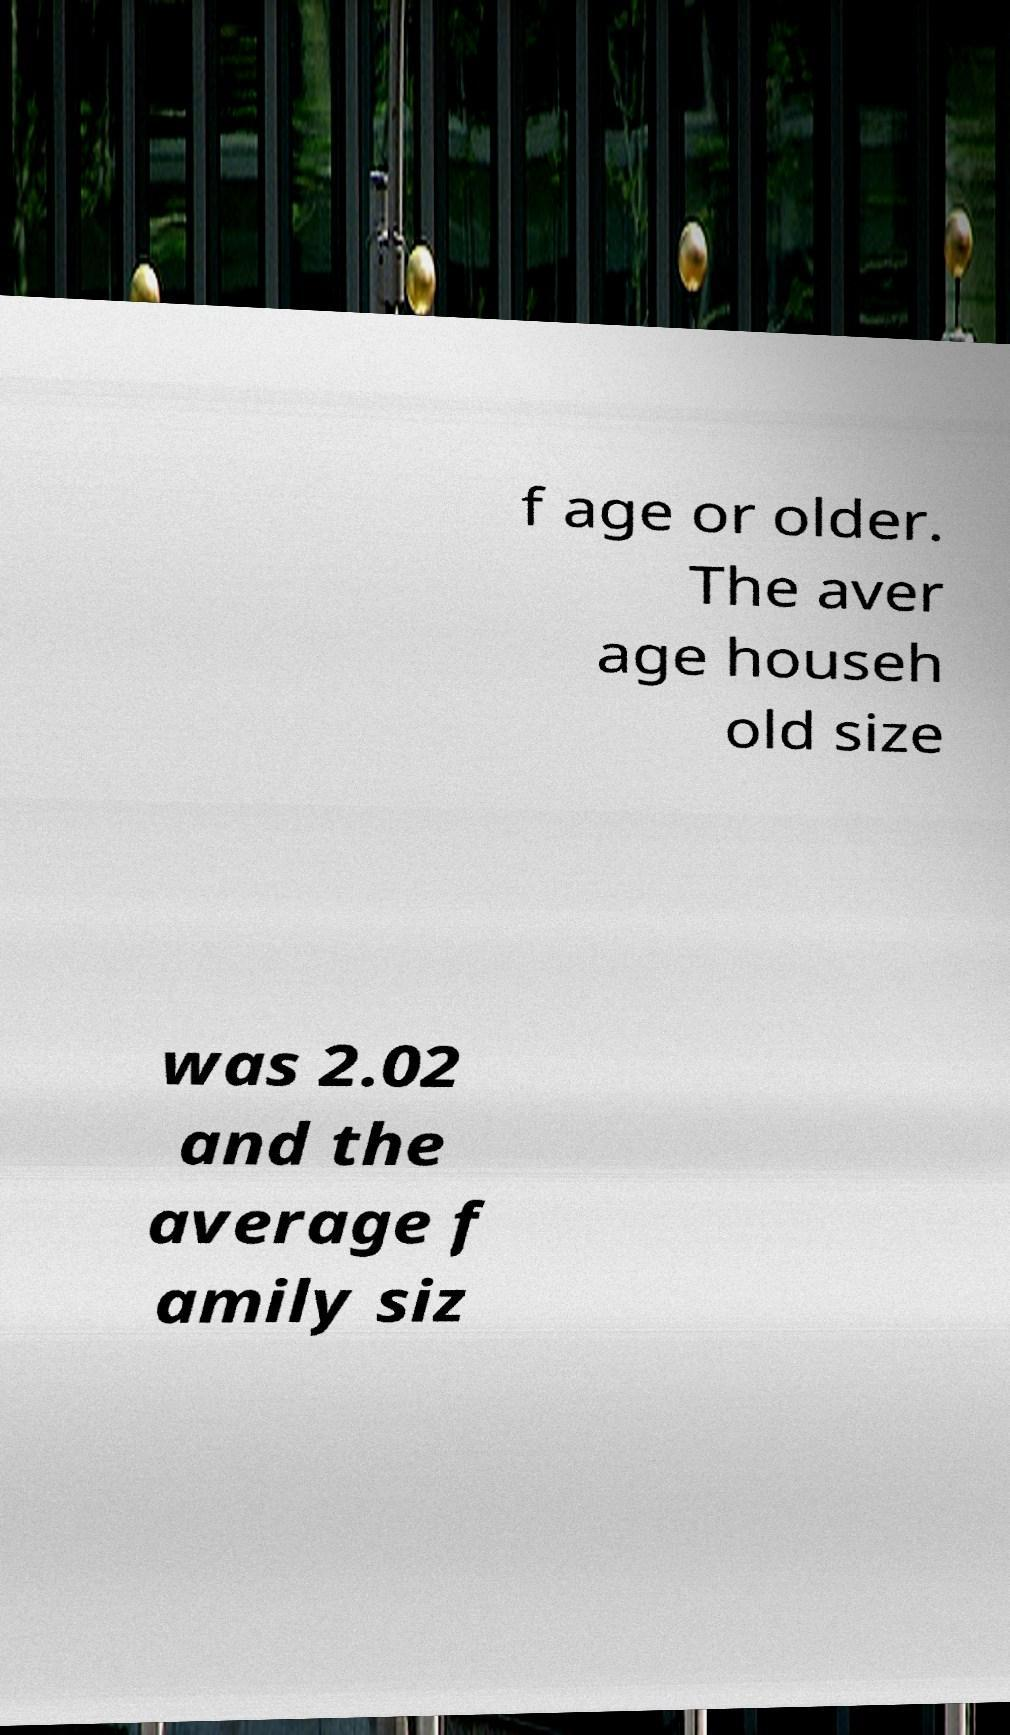There's text embedded in this image that I need extracted. Can you transcribe it verbatim? f age or older. The aver age househ old size was 2.02 and the average f amily siz 